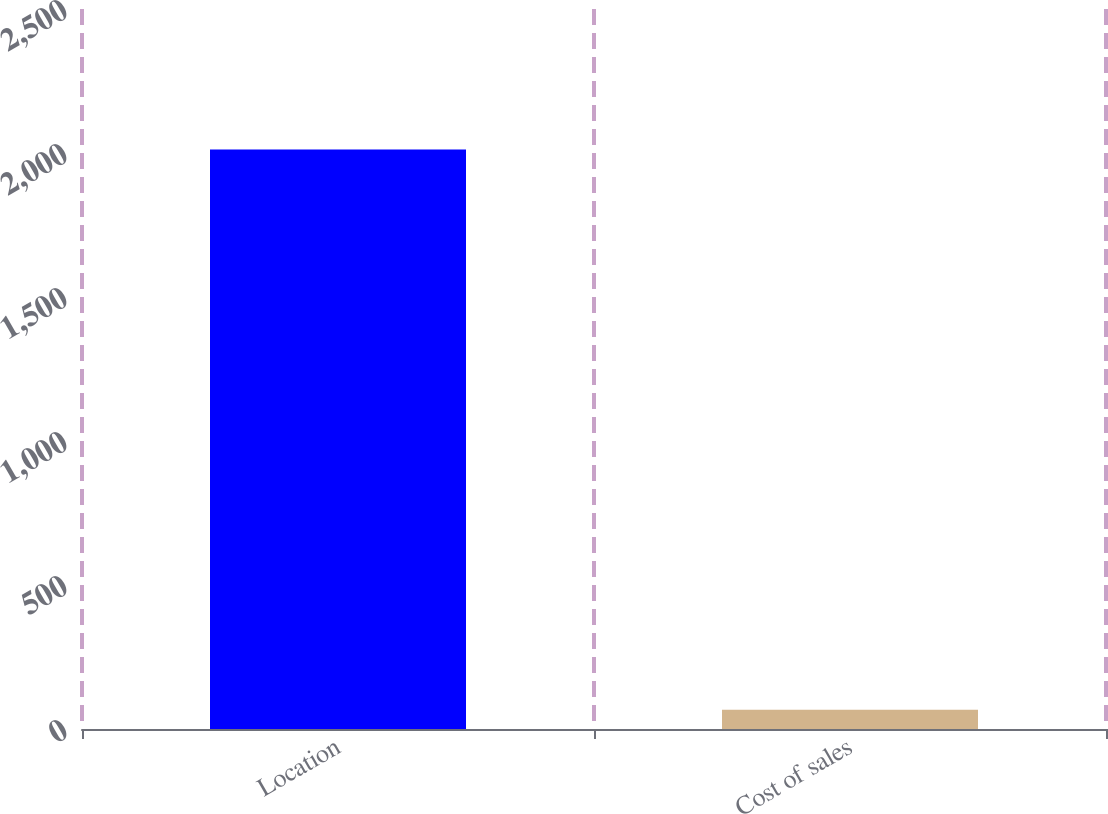<chart> <loc_0><loc_0><loc_500><loc_500><bar_chart><fcel>Location<fcel>Cost of sales<nl><fcel>2012<fcel>66.5<nl></chart> 